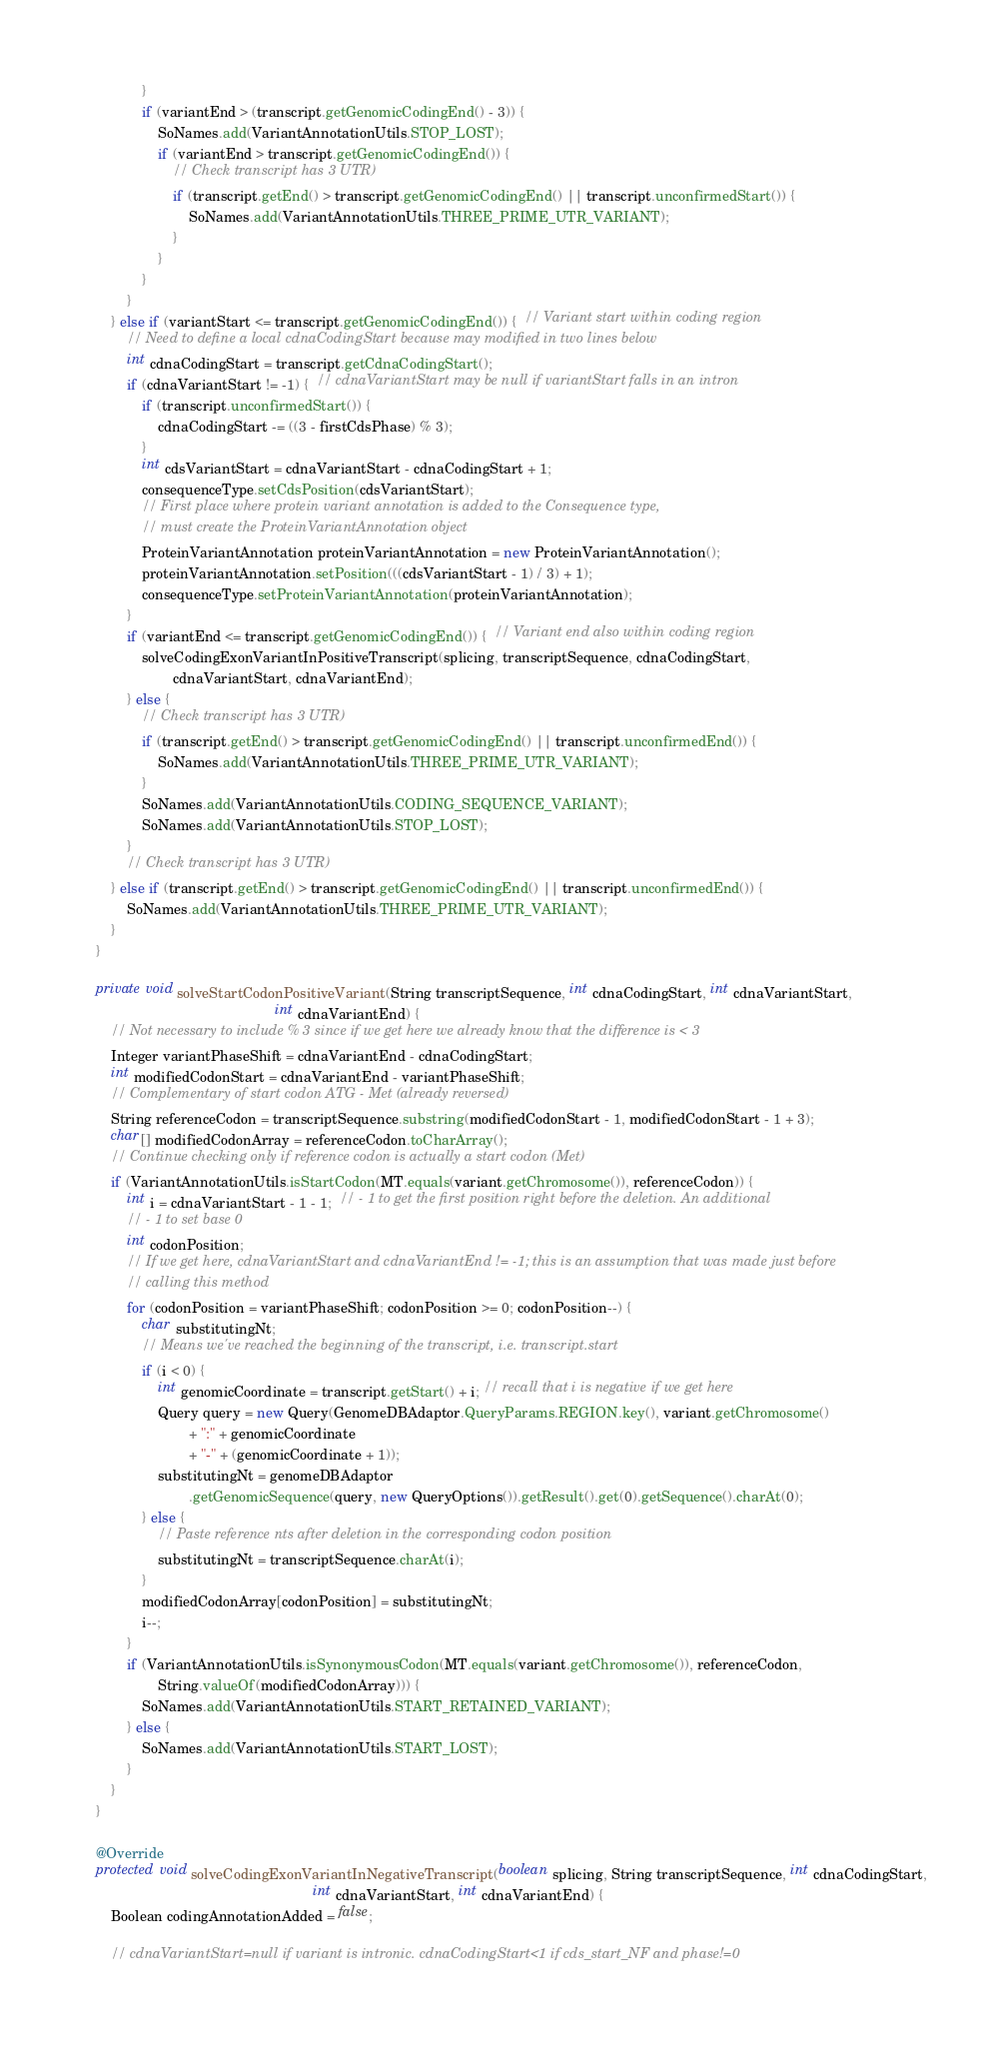<code> <loc_0><loc_0><loc_500><loc_500><_Java_>                }
                if (variantEnd > (transcript.getGenomicCodingEnd() - 3)) {
                    SoNames.add(VariantAnnotationUtils.STOP_LOST);
                    if (variantEnd > transcript.getGenomicCodingEnd()) {
                        // Check transcript has 3 UTR)
                        if (transcript.getEnd() > transcript.getGenomicCodingEnd() || transcript.unconfirmedStart()) {
                            SoNames.add(VariantAnnotationUtils.THREE_PRIME_UTR_VARIANT);
                        }
                    }
                }
            }
        } else if (variantStart <= transcript.getGenomicCodingEnd()) {  // Variant start within coding region
            // Need to define a local cdnaCodingStart because may modified in two lines below
            int cdnaCodingStart = transcript.getCdnaCodingStart();
            if (cdnaVariantStart != -1) {  // cdnaVariantStart may be null if variantStart falls in an intron
                if (transcript.unconfirmedStart()) {
                    cdnaCodingStart -= ((3 - firstCdsPhase) % 3);
                }
                int cdsVariantStart = cdnaVariantStart - cdnaCodingStart + 1;
                consequenceType.setCdsPosition(cdsVariantStart);
                // First place where protein variant annotation is added to the Consequence type,
                // must create the ProteinVariantAnnotation object
                ProteinVariantAnnotation proteinVariantAnnotation = new ProteinVariantAnnotation();
                proteinVariantAnnotation.setPosition(((cdsVariantStart - 1) / 3) + 1);
                consequenceType.setProteinVariantAnnotation(proteinVariantAnnotation);
            }
            if (variantEnd <= transcript.getGenomicCodingEnd()) {  // Variant end also within coding region
                solveCodingExonVariantInPositiveTranscript(splicing, transcriptSequence, cdnaCodingStart,
                        cdnaVariantStart, cdnaVariantEnd);
            } else {
                // Check transcript has 3 UTR)
                if (transcript.getEnd() > transcript.getGenomicCodingEnd() || transcript.unconfirmedEnd()) {
                    SoNames.add(VariantAnnotationUtils.THREE_PRIME_UTR_VARIANT);
                }
                SoNames.add(VariantAnnotationUtils.CODING_SEQUENCE_VARIANT);
                SoNames.add(VariantAnnotationUtils.STOP_LOST);
            }
            // Check transcript has 3 UTR)
        } else if (transcript.getEnd() > transcript.getGenomicCodingEnd() || transcript.unconfirmedEnd()) {
            SoNames.add(VariantAnnotationUtils.THREE_PRIME_UTR_VARIANT);
        }
    }

    private void solveStartCodonPositiveVariant(String transcriptSequence, int cdnaCodingStart, int cdnaVariantStart,
                                                  int cdnaVariantEnd) {
        // Not necessary to include % 3 since if we get here we already know that the difference is < 3
        Integer variantPhaseShift = cdnaVariantEnd - cdnaCodingStart;
        int modifiedCodonStart = cdnaVariantEnd - variantPhaseShift;
        // Complementary of start codon ATG - Met (already reversed)
        String referenceCodon = transcriptSequence.substring(modifiedCodonStart - 1, modifiedCodonStart - 1 + 3);
        char[] modifiedCodonArray = referenceCodon.toCharArray();
        // Continue checking only if reference codon is actually a start codon (Met)
        if (VariantAnnotationUtils.isStartCodon(MT.equals(variant.getChromosome()), referenceCodon)) {
            int i = cdnaVariantStart - 1 - 1;  // - 1 to get the first position right before the deletion. An additional
            // - 1 to set base 0
            int codonPosition;
            // If we get here, cdnaVariantStart and cdnaVariantEnd != -1; this is an assumption that was made just before
            // calling this method
            for (codonPosition = variantPhaseShift; codonPosition >= 0; codonPosition--) {
                char substitutingNt;
                // Means we've reached the beginning of the transcript, i.e. transcript.start
                if (i < 0) {
                    int genomicCoordinate = transcript.getStart() + i; // recall that i is negative if we get here
                    Query query = new Query(GenomeDBAdaptor.QueryParams.REGION.key(), variant.getChromosome()
                            + ":" + genomicCoordinate
                            + "-" + (genomicCoordinate + 1));
                    substitutingNt = genomeDBAdaptor
                            .getGenomicSequence(query, new QueryOptions()).getResult().get(0).getSequence().charAt(0);
                } else {
                    // Paste reference nts after deletion in the corresponding codon position
                    substitutingNt = transcriptSequence.charAt(i);
                }
                modifiedCodonArray[codonPosition] = substitutingNt;
                i--;
            }
            if (VariantAnnotationUtils.isSynonymousCodon(MT.equals(variant.getChromosome()), referenceCodon,
                    String.valueOf(modifiedCodonArray))) {
                SoNames.add(VariantAnnotationUtils.START_RETAINED_VARIANT);
            } else {
                SoNames.add(VariantAnnotationUtils.START_LOST);
            }
        }
    }

    @Override
    protected void solveCodingExonVariantInNegativeTranscript(boolean splicing, String transcriptSequence, int cdnaCodingStart,
                                                            int cdnaVariantStart, int cdnaVariantEnd) {
        Boolean codingAnnotationAdded = false;

        // cdnaVariantStart=null if variant is intronic. cdnaCodingStart<1 if cds_start_NF and phase!=0</code> 